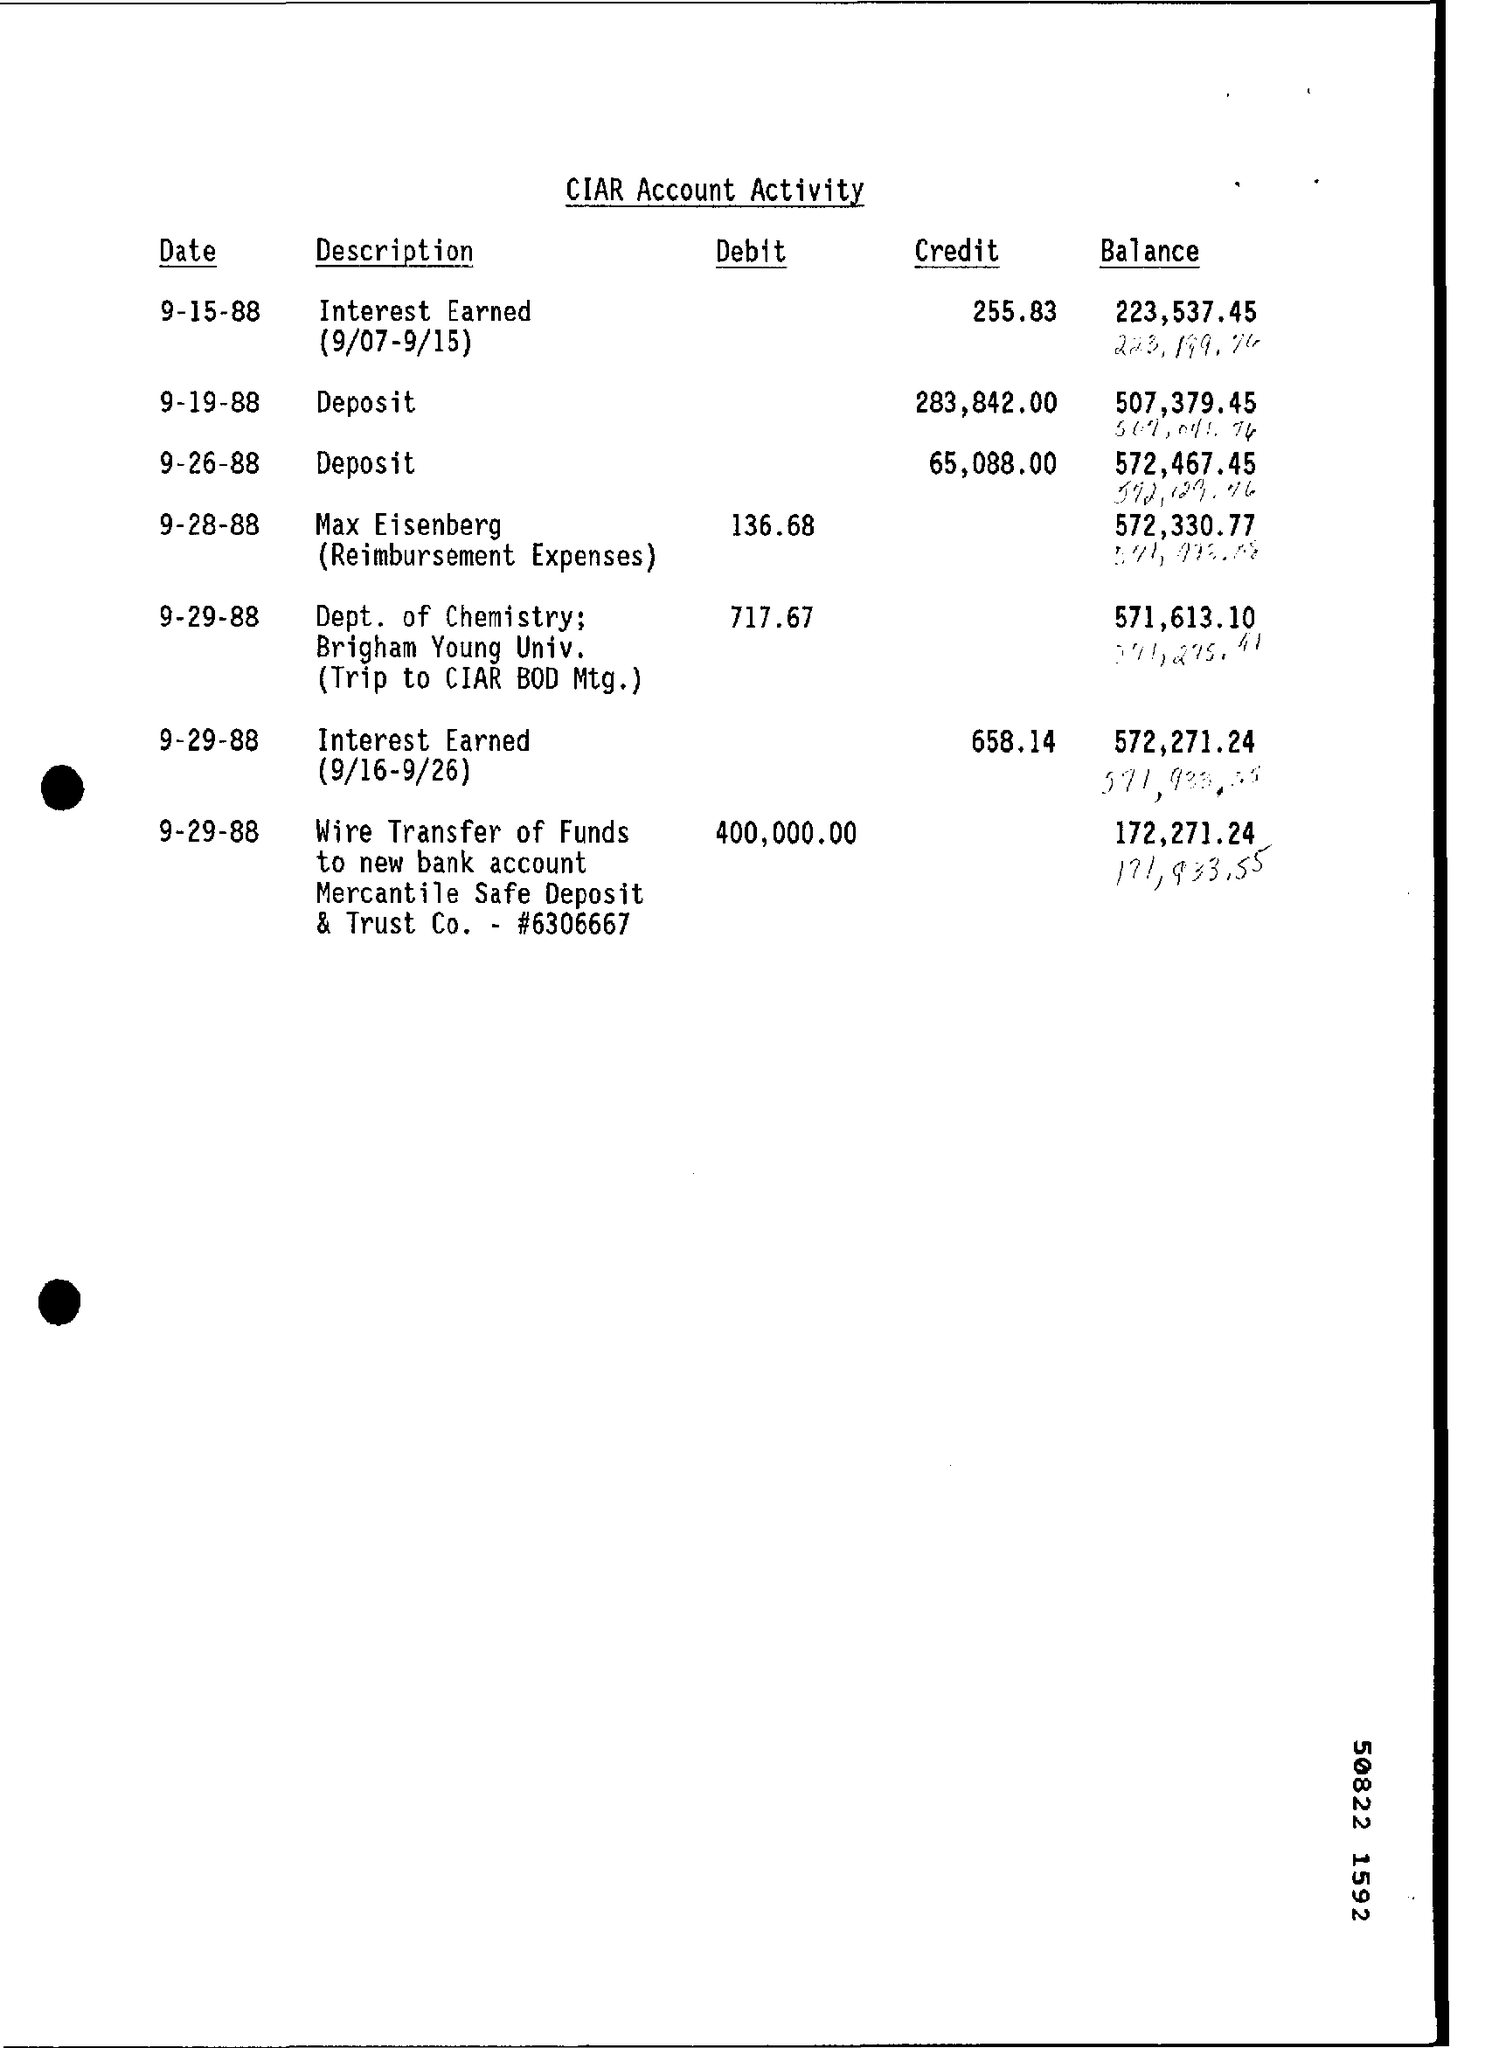Specify some key components in this picture. On September 26, 1988, a credit of 65,088.00 was made for a deposit. On September 29, 1988, Merchant Safe Deposit & Trust Co. debited an amount of 400,000.00. The description for the credited amount of 255.83 on September 15, 1988 is "Interest Earned from September 7 to September 15, 1988. 